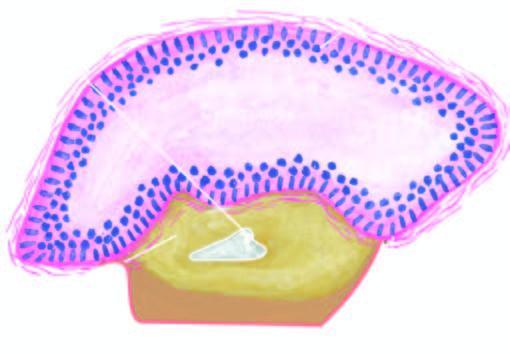re inflammatory changes conspicuously absent?
Answer the question using a single word or phrase. Yes 